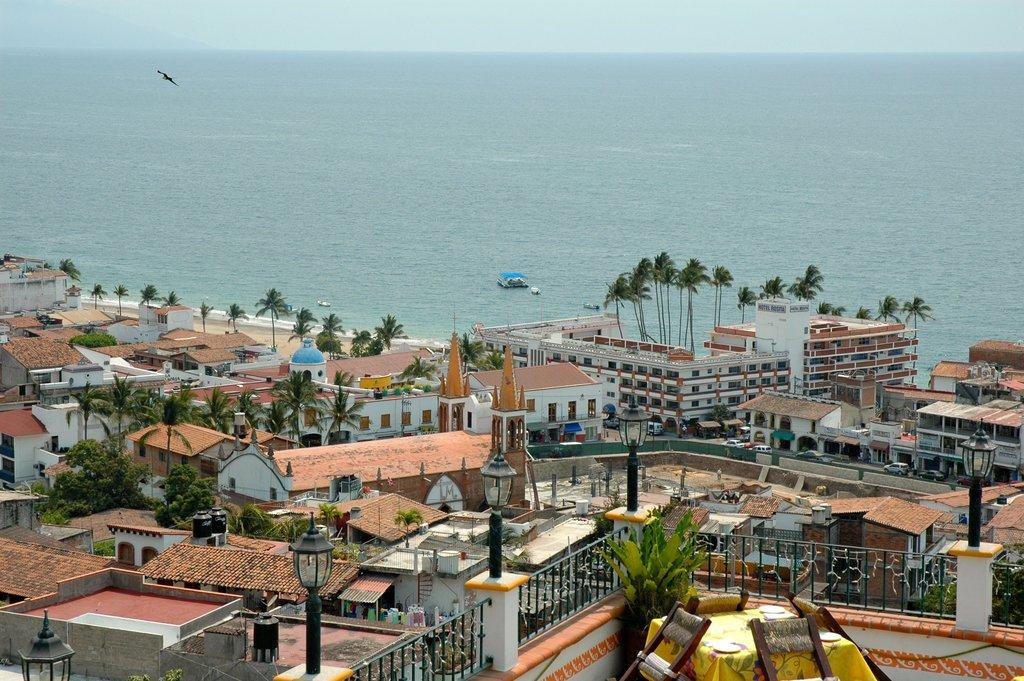What types of structures can be seen in the image? There are many buildings and houses in the image. What natural elements are present in the image? There are trees and plants in the image. What architectural features can be observed in the image? There are railings and poles in the image. What is visible in the background of the image? The background of the image includes the sea, boats, a bird, and the sky. How does the turkey feel about the pleasure it gets from the tail in the image? There is no turkey or any reference to pleasure or a tail in the image. 